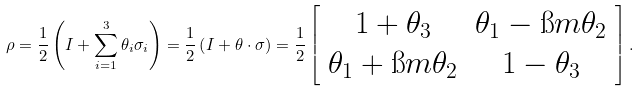<formula> <loc_0><loc_0><loc_500><loc_500>\rho = \frac { 1 } { 2 } \left ( I + \sum _ { i = 1 } ^ { 3 } \theta _ { i } \sigma _ { i } \right ) = \frac { 1 } { 2 } \left ( I + \theta \cdot \sigma \right ) = \frac { 1 } { 2 } \left [ \begin{array} { c c } 1 + \theta _ { 3 } & \theta _ { 1 } - \i m \theta _ { 2 } \\ \theta _ { 1 } + \i m \theta _ { 2 } & 1 - \theta _ { 3 } \end{array} \right ] .</formula> 